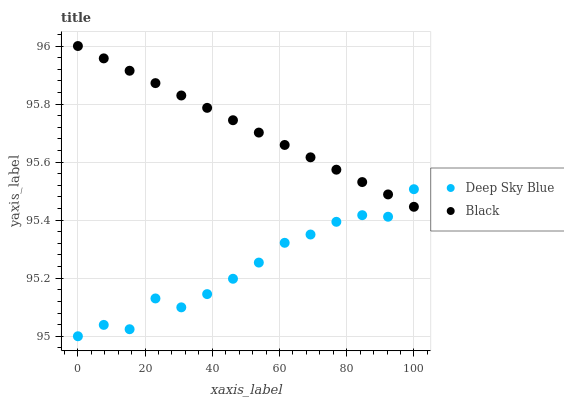Does Deep Sky Blue have the minimum area under the curve?
Answer yes or no. Yes. Does Black have the maximum area under the curve?
Answer yes or no. Yes. Does Deep Sky Blue have the maximum area under the curve?
Answer yes or no. No. Is Black the smoothest?
Answer yes or no. Yes. Is Deep Sky Blue the roughest?
Answer yes or no. Yes. Is Deep Sky Blue the smoothest?
Answer yes or no. No. Does Deep Sky Blue have the lowest value?
Answer yes or no. Yes. Does Black have the highest value?
Answer yes or no. Yes. Does Deep Sky Blue have the highest value?
Answer yes or no. No. Does Black intersect Deep Sky Blue?
Answer yes or no. Yes. Is Black less than Deep Sky Blue?
Answer yes or no. No. Is Black greater than Deep Sky Blue?
Answer yes or no. No. 